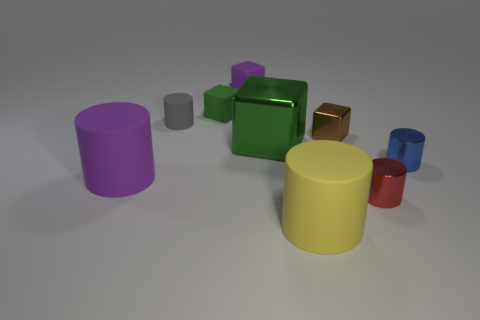The large cylinder that is right of the purple cylinder is what color?
Provide a short and direct response. Yellow. Is the number of big yellow things that are in front of the purple rubber block greater than the number of green metal blocks?
Provide a succinct answer. No. Is the material of the purple cylinder the same as the tiny green cube?
Make the answer very short. Yes. What number of other objects are the same shape as the small blue thing?
Your response must be concise. 4. Is there any other thing that has the same material as the small blue thing?
Provide a short and direct response. Yes. What color is the small cylinder in front of the small metallic object to the right of the metallic object that is in front of the tiny blue object?
Your answer should be compact. Red. There is a small green object that is on the left side of the large cube; is its shape the same as the tiny blue object?
Your response must be concise. No. How many large red cubes are there?
Provide a succinct answer. 0. How many brown metallic spheres have the same size as the gray rubber cylinder?
Keep it short and to the point. 0. What material is the small green cube?
Your answer should be very brief. Rubber. 